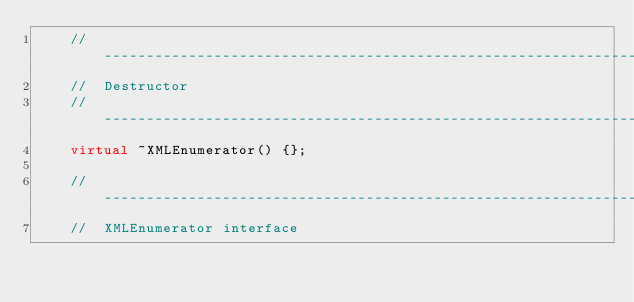Convert code to text. <code><loc_0><loc_0><loc_500><loc_500><_C++_>    // -----------------------------------------------------------------------
    //  Destructor
    // -----------------------------------------------------------------------
    virtual ~XMLEnumerator() {};

    // -----------------------------------------------------------------------
    //  XMLEnumerator interface</code> 